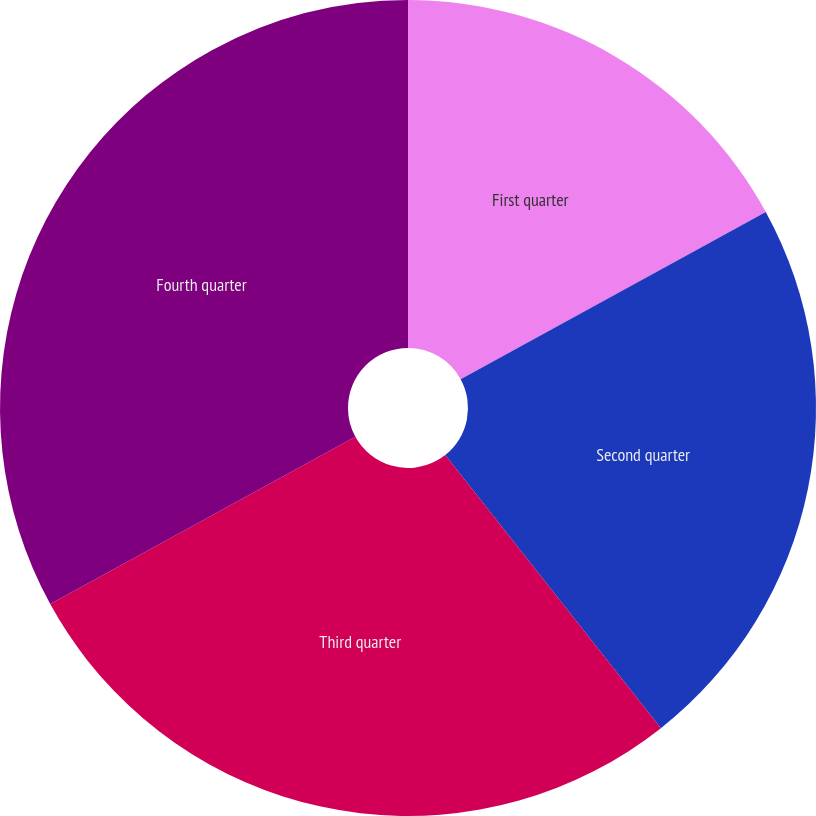Convert chart. <chart><loc_0><loc_0><loc_500><loc_500><pie_chart><fcel>First quarter<fcel>Second quarter<fcel>Third quarter<fcel>Fourth quarter<nl><fcel>17.02%<fcel>22.34%<fcel>27.66%<fcel>32.98%<nl></chart> 